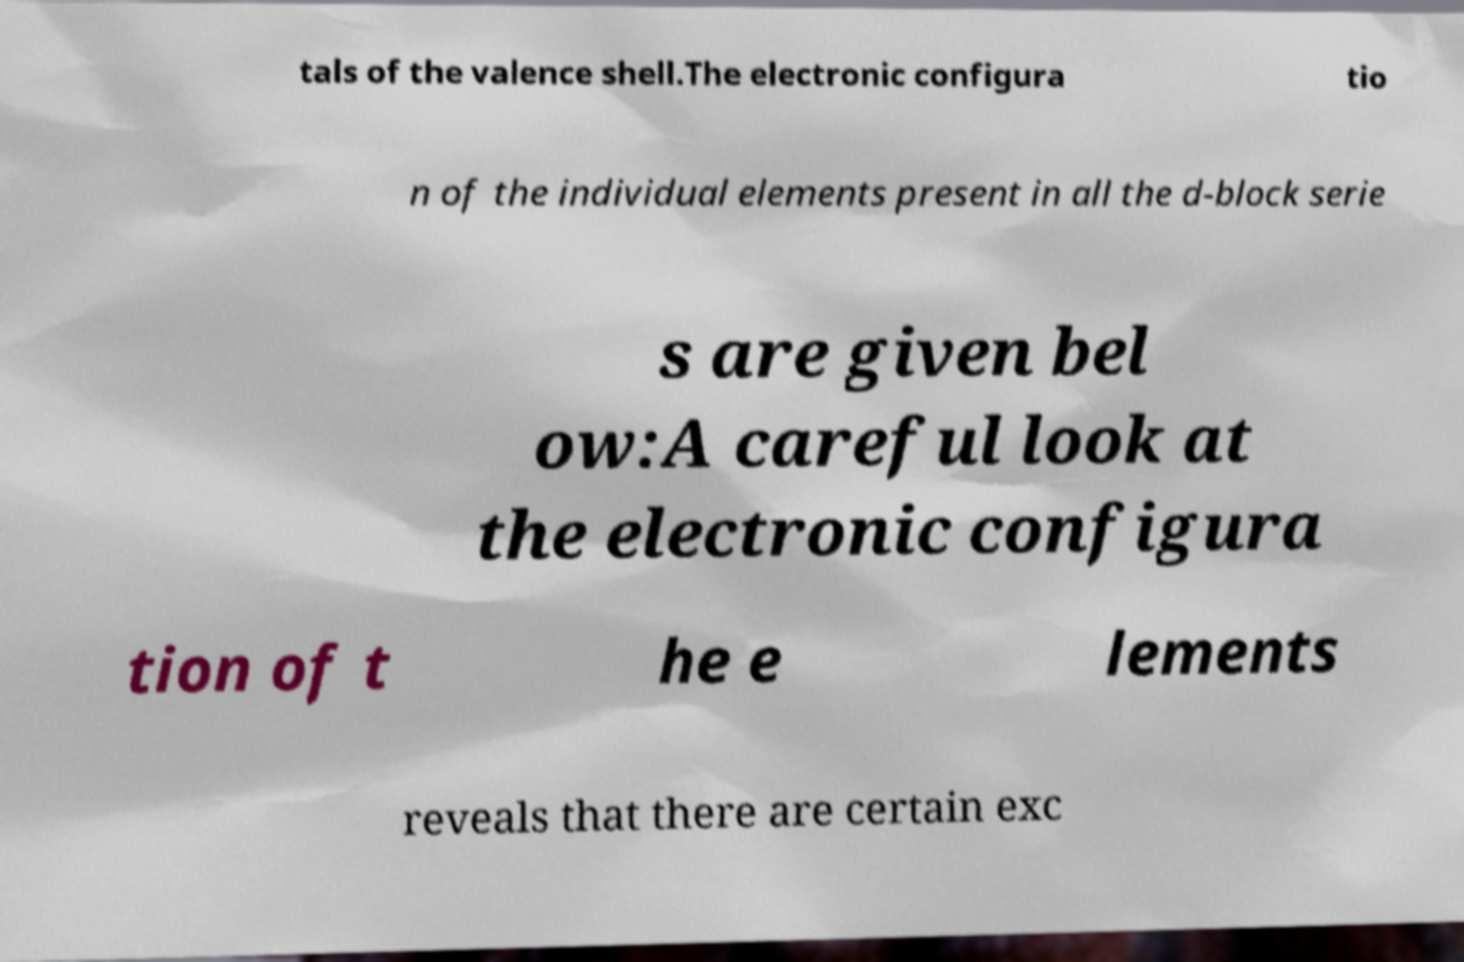What messages or text are displayed in this image? I need them in a readable, typed format. tals of the valence shell.The electronic configura tio n of the individual elements present in all the d-block serie s are given bel ow:A careful look at the electronic configura tion of t he e lements reveals that there are certain exc 